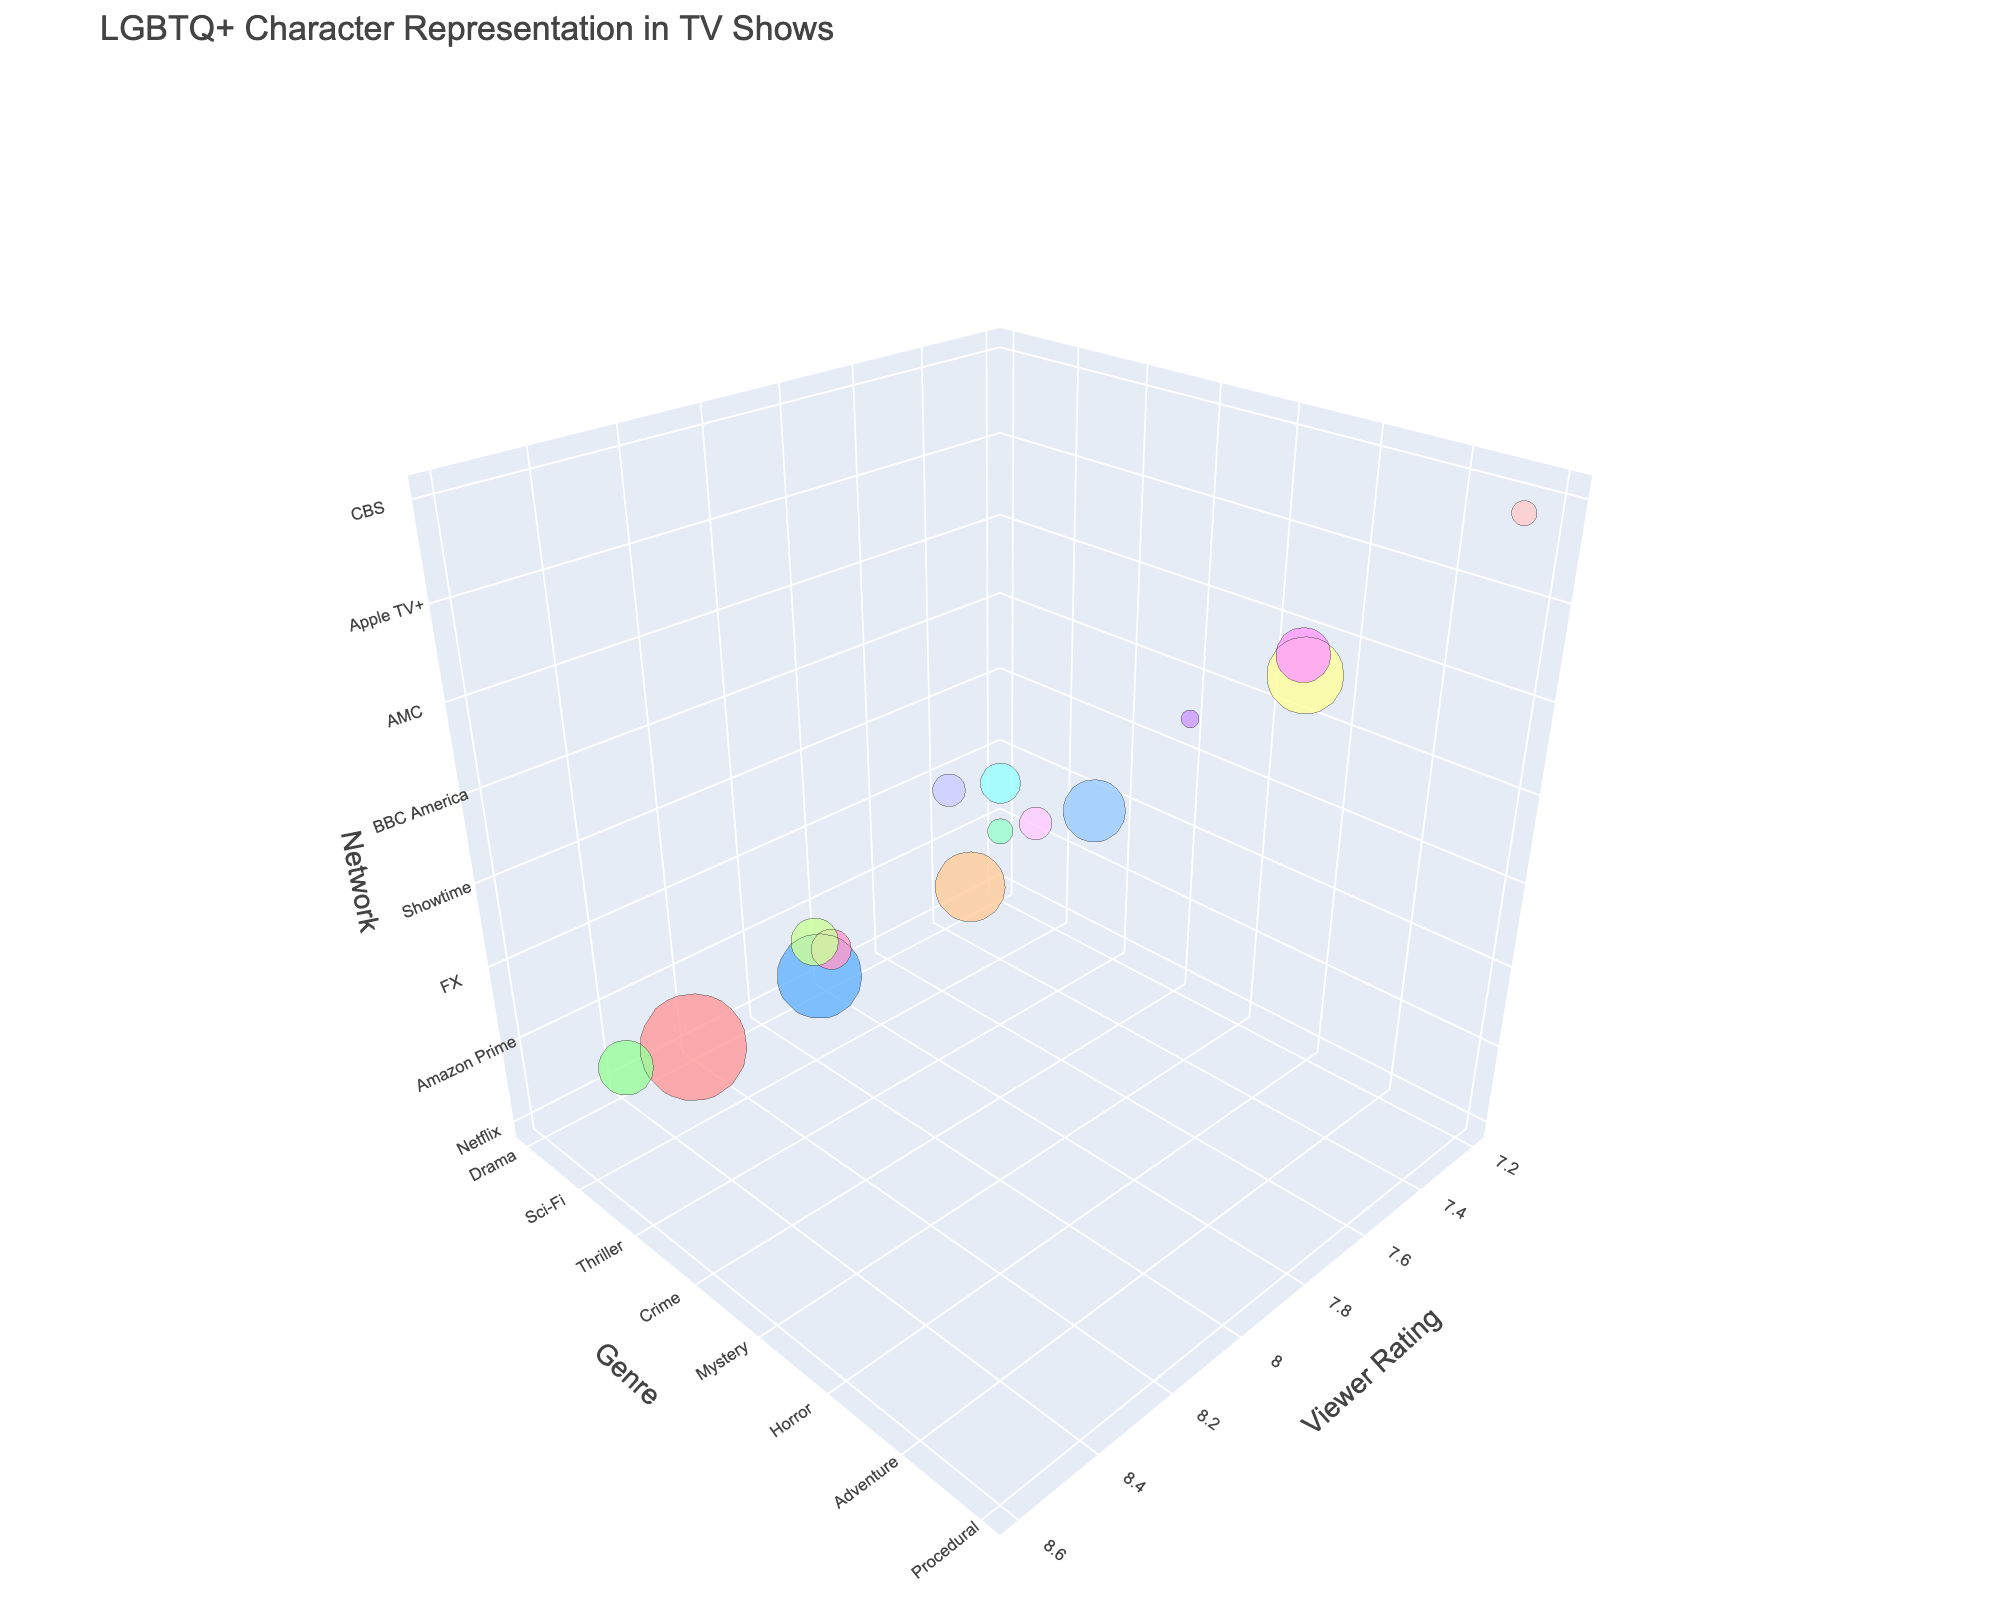How many networks have LGBTQ+ characters in the chart? The figure includes several data points, each representing a different network. Counting the unique networks provided in the plot, we get a total of 15.
Answer: 15 Which network has the highest viewer rating for shows with LGBTQ+ characters? Looking at the viewer ratings along the x-axis and finding the maximum value, the highest viewer rating is 8.6 which belongs to a show on Disney+.
Answer: Disney+ Which network has the most LGBTQ+ characters and what is the viewer rating for that network? By identifying the largest bubble size and checking its corresponding text, we see that Netflix has the highest LGBTQ+ character count with 15 characters. The viewer rating for Netflix is 8.2.
Answer: Netflix Between HBO and Freeform, which genre contains more LGBTQ+ characters and what are their counts? HBO is associated with Comedy genre and has 12 LGBTQ+ characters, while Freeform is associated with Teen genre and has 11 LGBTQ+ characters. So, HBO contains more characters by one.
Answer: HBO, 12 What is the average viewer rating for shows containing LGBTQ+ characters on networks Amazon Prime and Apple TV+? Amazon Prime has a viewer rating of 8.5 and Apple TV+ has a viewer rating of 8.4. The average is calculated as (8.5 + 8.4) / 2 = 8.45.
Answer: 8.45 Which genre has the smallest bubble size and what network is associated with it? The smallest bubble size corresponds to the genre with the least LGBTQ+ characters. The Mystery genre has the smallest bubble size and is associated with BBC America, having 4 LGBTQ+ characters.
Answer: Mystery, BBC America Which network has a higher LGBTQ+ character count, Hulu or CW? Looking at the bubble sizes, Hulu has 10 LGBTQ+ characters for Romance genre and CW has 9 LGBTQ+ characters for Superhero genre. Therefore, Hulu has a higher count.
Answer: Hulu What is the difference in viewer ratings between FX and Starz networks? FX has a viewer rating of 8.1 and Starz has a viewer rating of 7.8. The difference is 8.1 - 7.8 = 0.3.
Answer: 0.3 Which genre represented by AMC has LGBTQ+ characters, and how many are there? The genre associated with AMC is Horror, and it has 3 LGBTQ+ characters.
Answer: Horror, 3 How do the number of LGBTQ+ characters in shows on CBS compare to those on FX? CBS, associated with the Procedural genre, has 4 LGBTQ+ characters, whereas FX, associated with the Thriller genre, has 6 LGBTQ+ characters. FX has 2 more LGBTQ+ characters than CBS.
Answer: FX (2 more) 